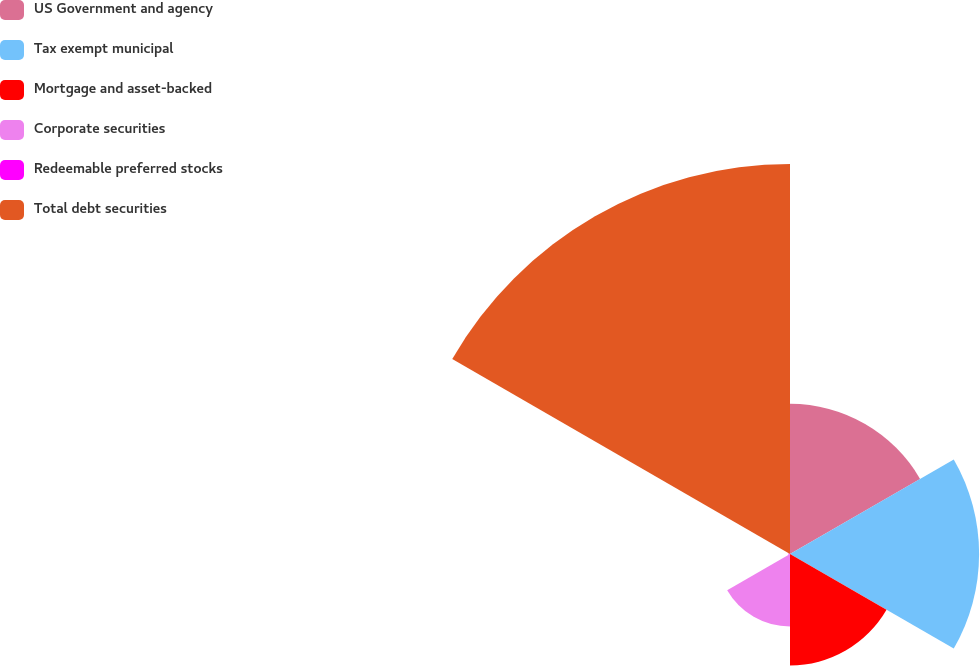Convert chart. <chart><loc_0><loc_0><loc_500><loc_500><pie_chart><fcel>US Government and agency<fcel>Tax exempt municipal<fcel>Mortgage and asset-backed<fcel>Corporate securities<fcel>Redeemable preferred stocks<fcel>Total debt securities<nl><fcel>16.42%<fcel>20.67%<fcel>12.18%<fcel>7.93%<fcel>0.17%<fcel>42.63%<nl></chart> 